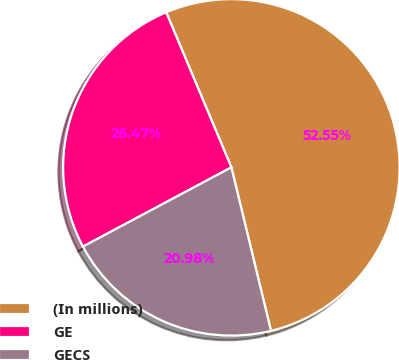Convert chart. <chart><loc_0><loc_0><loc_500><loc_500><pie_chart><fcel>(In millions)<fcel>GE<fcel>GECS<nl><fcel>52.55%<fcel>26.47%<fcel>20.98%<nl></chart> 